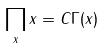Convert formula to latex. <formula><loc_0><loc_0><loc_500><loc_500>\prod _ { x } x = C \Gamma ( x )</formula> 